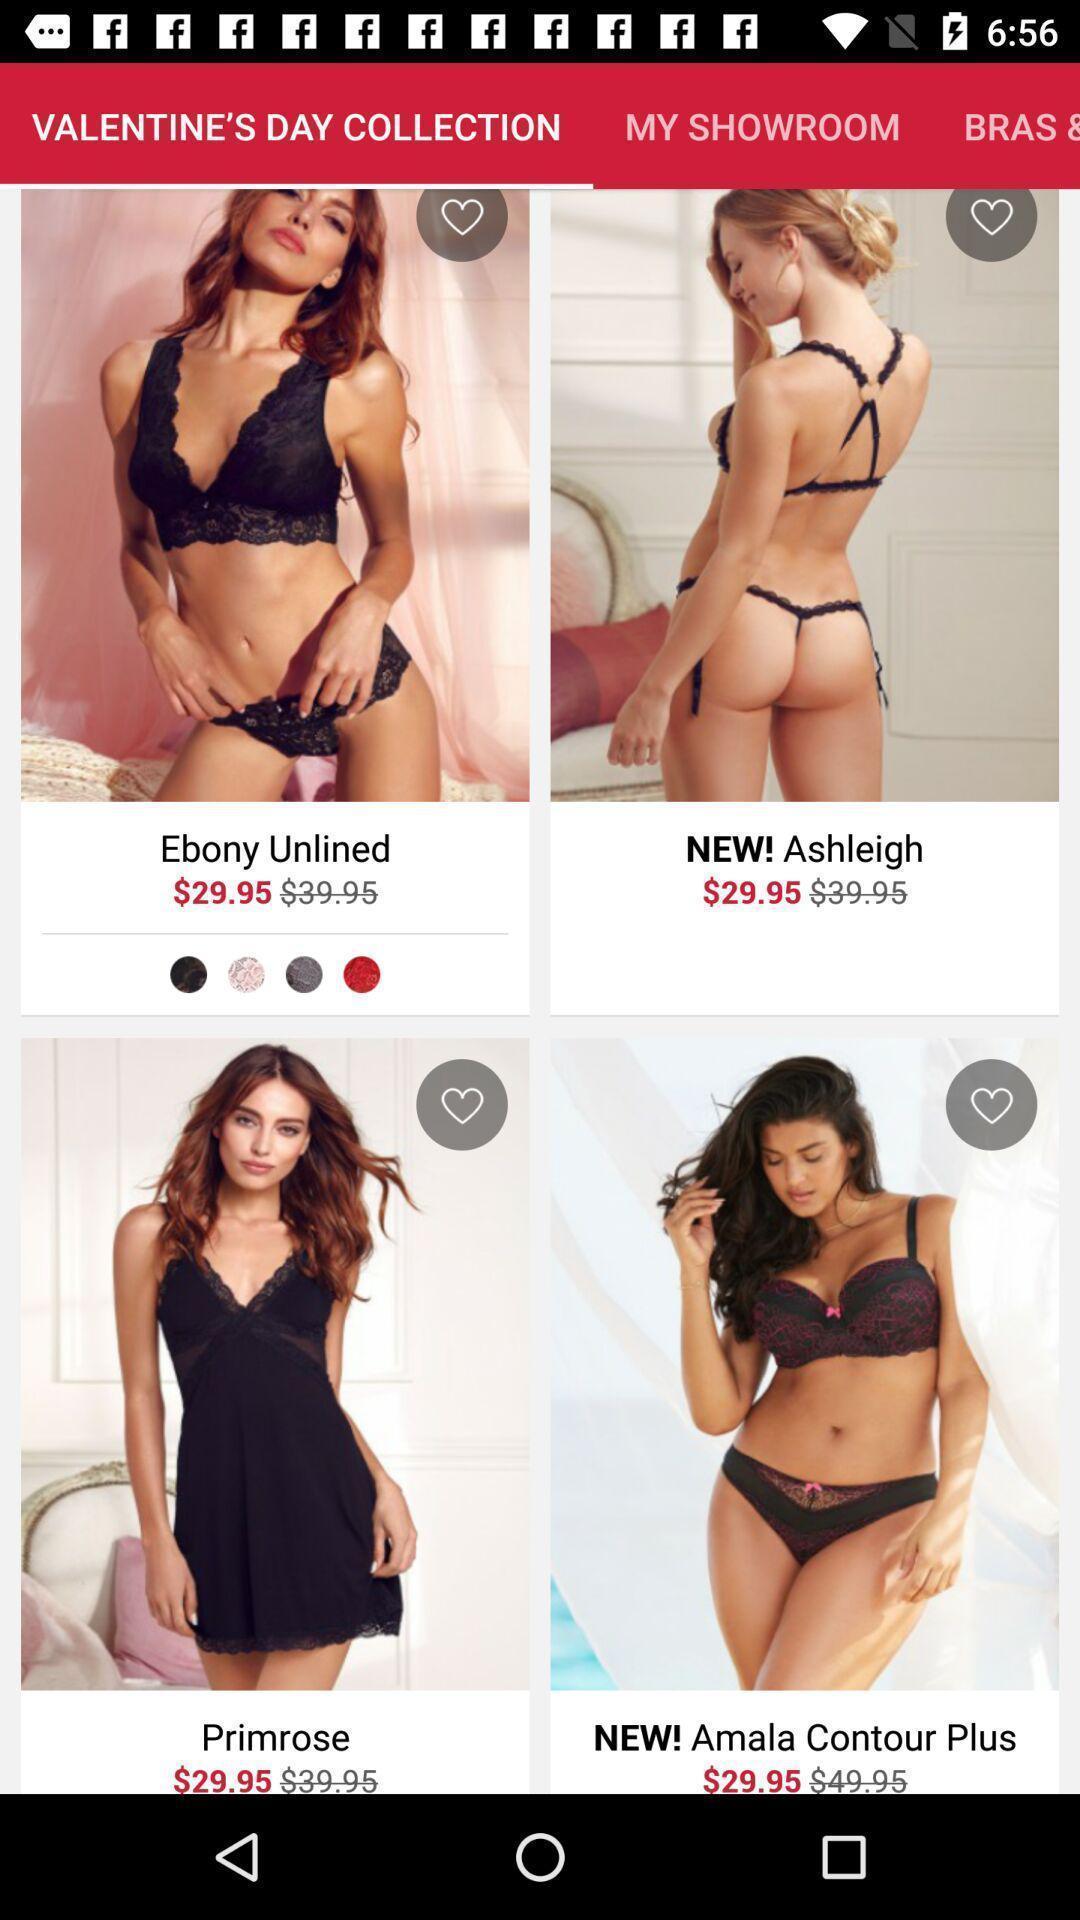Provide a textual representation of this image. Screen shows products in a shopping application. 